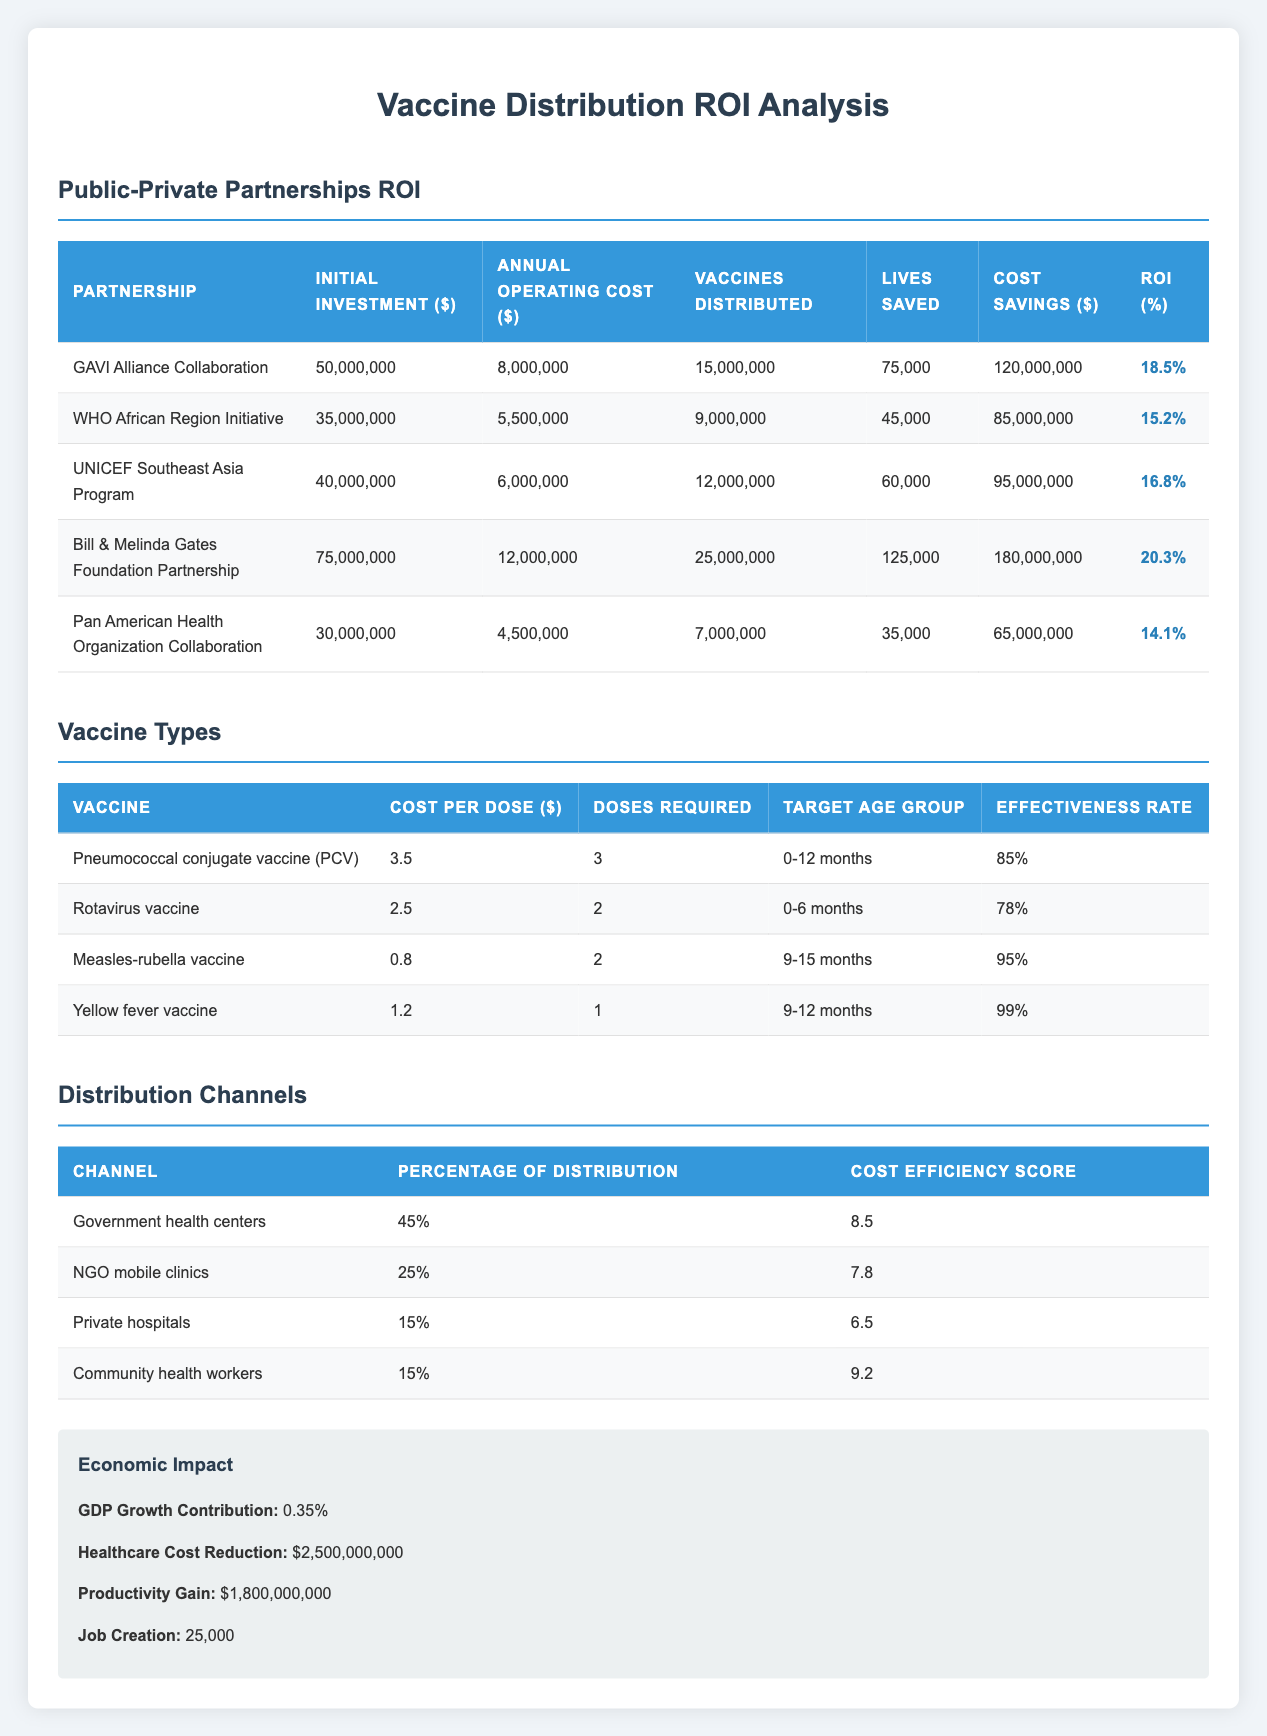What is the initial investment for the Bill & Melinda Gates Foundation Partnership? The table shows the initial investment for each partnership. For the Bill & Melinda Gates Foundation Partnership, the initial investment is listed as 75,000,000.
Answer: 75,000,000 Which partnership has the highest ROI percentage? By comparing the ROI percentages listed for each partnership, the Bill & Melinda Gates Foundation Partnership has the highest ROI percentage at 20.3%.
Answer: Bill & Melinda Gates Foundation Partnership What is the total cost savings for the partnerships listed? To find the total cost savings, add the cost savings for all the partnerships: 120,000,000 + 85,000,000 + 95,000,000 + 180,000,000 + 65,000,000 = 545,000,000.
Answer: 545,000,000 Is the annual operating cost for the WHO African Region Initiative less than the cost savings? The annual operating cost for the WHO African Region Initiative is 5,500,000, and the cost savings is 85,000,000. Since 5,500,000 is less than 85,000,000, the answer is yes.
Answer: Yes What is the average ROI percentage of all partnerships listed? To find the average ROI percentage, sum the ROI percentages (18.5 + 15.2 + 16.8 + 20.3 + 14.1 = 84.9) and divide by the number of partnerships (5): 84.9 / 5 = 16.98.
Answer: 16.98 Which partnership saved the most lives per vaccine distributed? To find the lives saved per vaccine distributed for each partnership, divide the number of lives saved by the number of vaccines distributed: GAVI (75,000/15,000,000 = 0.005), WHO (45,000/9,000,000 = 0.005), UNICEF (60,000/12,000,000 = 0.005), Gates (125,000/25,000,000 = 0.005), PAHO (35,000/7,000,000 = 0.005). All partnerships saved the same lives per vaccine distributed (0.005).
Answer: All saved 0.005 lives per vaccine distributed Is the annual operating cost for the GAVI Alliance Collaboration higher than that of the Pan American Health Organization Collaboration? The annual operating cost for the GAVI Alliance Collaboration is 8,000,000, and for the Pan American Health Organization Collaboration, it is 4,500,000. Since 8,000,000 is greater than 4,500,000, the answer is yes.
Answer: Yes How many vaccines were distributed in total by the partnerships? To find the total vaccines distributed, add the vaccines distributed for all partnerships: 15,000,000 + 9,000,000 + 12,000,000 + 25,000,000 + 7,000,000 = 68,000,000.
Answer: 68,000,000 What percentage of vaccines were distributed through Government health centers? The table states that 45% of vaccines were distributed through Government health centers. This is a retrieval question answered directly from the table.
Answer: 45% 